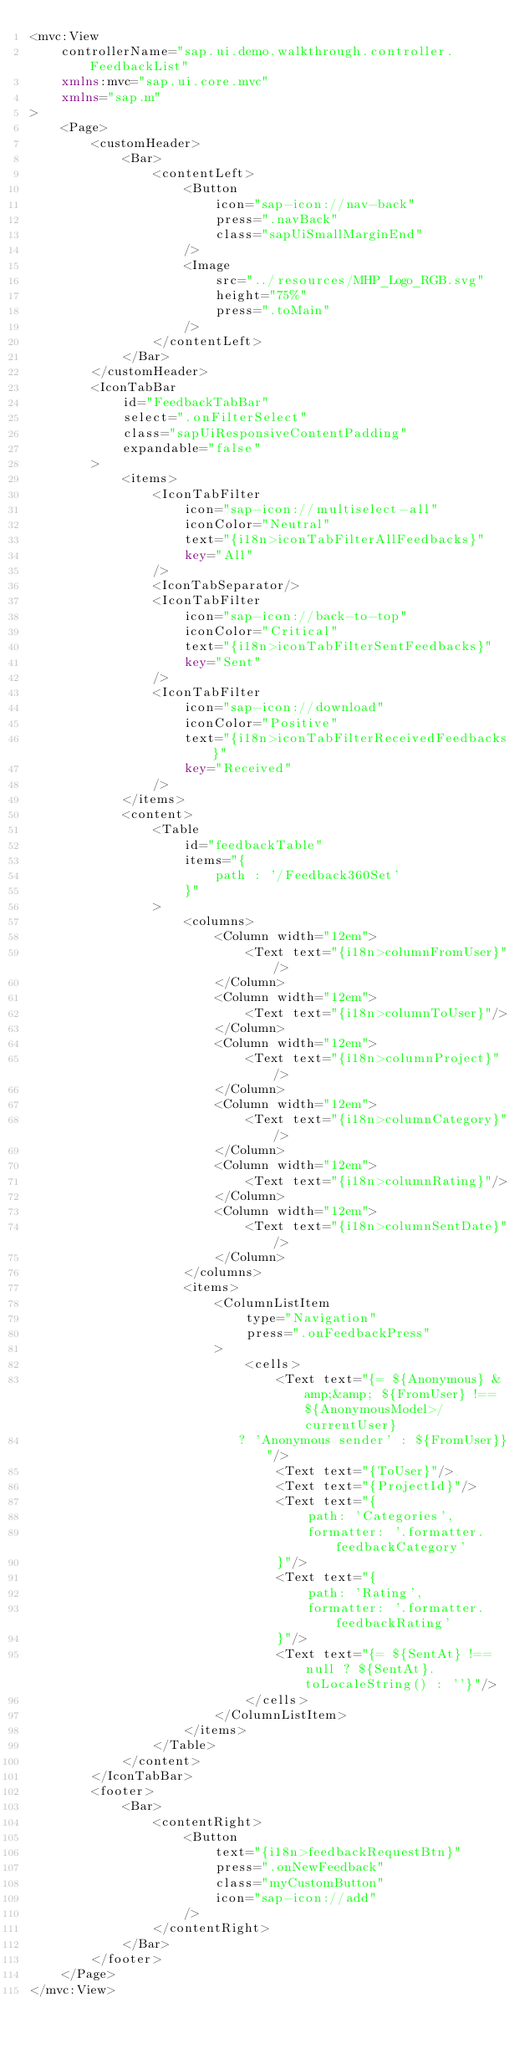Convert code to text. <code><loc_0><loc_0><loc_500><loc_500><_XML_><mvc:View
	controllerName="sap.ui.demo.walkthrough.controller.FeedbackList"
	xmlns:mvc="sap.ui.core.mvc"
	xmlns="sap.m"
>
	<Page>
		<customHeader>
			<Bar>
				<contentLeft>
					<Button
						icon="sap-icon://nav-back"
						press=".navBack"
						class="sapUiSmallMarginEnd"
					/>
					<Image
						src="../resources/MHP_Logo_RGB.svg"
						height="75%"
						press=".toMain"
					/>
				</contentLeft>
			</Bar>
		</customHeader>
		<IconTabBar
			id="FeedbackTabBar"
			select=".onFilterSelect"
			class="sapUiResponsiveContentPadding"
			expandable="false"
		>
			<items>
				<IconTabFilter
					icon="sap-icon://multiselect-all"
					iconColor="Neutral"
					text="{i18n>iconTabFilterAllFeedbacks}"
					key="All"
				/>
				<IconTabSeparator/>
				<IconTabFilter
					icon="sap-icon://back-to-top"
					iconColor="Critical"
					text="{i18n>iconTabFilterSentFeedbacks}"
					key="Sent"
				/>
				<IconTabFilter
					icon="sap-icon://download"
					iconColor="Positive"
					text="{i18n>iconTabFilterReceivedFeedbacks}"
					key="Received"
				/>
			</items>
			<content>
				<Table
					id="feedbackTable"
					items="{
						path : '/Feedback360Set'
					}"
				>
					<columns>
						<Column width="12em">
							<Text text="{i18n>columnFromUser}"/>
						</Column>
						<Column width="12em">
							<Text text="{i18n>columnToUser}"/>
						</Column>
						<Column width="12em">
							<Text text="{i18n>columnProject}"/>
						</Column>
						<Column width="12em">
							<Text text="{i18n>columnCategory}"/>
						</Column>
						<Column width="12em">
							<Text text="{i18n>columnRating}"/>
						</Column>
						<Column width="12em">
							<Text text="{i18n>columnSentDate}"/>
						</Column>
					</columns>
					<items>
						<ColumnListItem
							type="Navigation"
							press=".onFeedbackPress"
						>
							<cells>
								<Text text="{= ${Anonymous} &amp;&amp; ${FromUser} !== ${AnonymousModel>/currentUser} 
                           ? 'Anonymous sender' : ${FromUser}}"/>
								<Text text="{ToUser}"/>
								<Text text="{ProjectId}"/>
								<Text text="{
									path: 'Categories',
									formatter: '.formatter.feedbackCategory'
								}"/>
								<Text text="{
									path: 'Rating',
									formatter: '.formatter.feedbackRating'
								}"/>
								<Text text="{= ${SentAt} !== null ? ${SentAt}.toLocaleString() : ''}"/>
							</cells>
						</ColumnListItem>
					</items>
				</Table>
			</content>
		</IconTabBar>
		<footer>
			<Bar>
				<contentRight>
					<Button
						text="{i18n>feedbackRequestBtn}"
						press=".onNewFeedback"
						class="myCustomButton"
						icon="sap-icon://add"
					/>
				</contentRight>
			</Bar>
		</footer>
	</Page>
</mvc:View></code> 